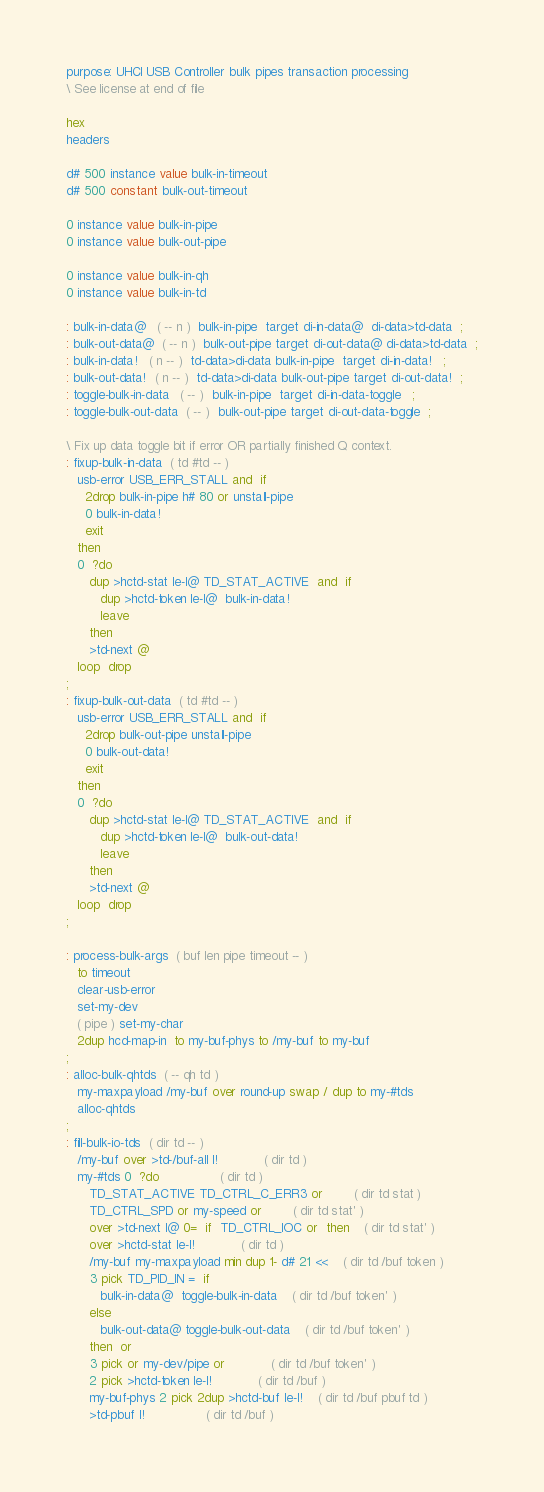<code> <loc_0><loc_0><loc_500><loc_500><_Forth_>purpose: UHCI USB Controller bulk pipes transaction processing
\ See license at end of file

hex
headers

d# 500 instance value bulk-in-timeout
d# 500 constant bulk-out-timeout

0 instance value bulk-in-pipe
0 instance value bulk-out-pipe

0 instance value bulk-in-qh
0 instance value bulk-in-td

: bulk-in-data@   ( -- n )  bulk-in-pipe  target di-in-data@  di-data>td-data  ;
: bulk-out-data@  ( -- n )  bulk-out-pipe target di-out-data@ di-data>td-data  ;
: bulk-in-data!   ( n -- )  td-data>di-data bulk-in-pipe  target di-in-data!   ;
: bulk-out-data!  ( n -- )  td-data>di-data bulk-out-pipe target di-out-data!  ;
: toggle-bulk-in-data   ( -- )  bulk-in-pipe  target di-in-data-toggle   ;
: toggle-bulk-out-data  ( -- )  bulk-out-pipe target di-out-data-toggle  ;

\ Fix up data toggle bit if error OR partially finished Q context.
: fixup-bulk-in-data  ( td #td -- )
   usb-error USB_ERR_STALL and  if
     2drop bulk-in-pipe h# 80 or unstall-pipe
     0 bulk-in-data!
     exit
   then
   0  ?do
      dup >hctd-stat le-l@ TD_STAT_ACTIVE  and  if
         dup >hctd-token le-l@  bulk-in-data!
         leave
      then
      >td-next @
   loop  drop
;
: fixup-bulk-out-data  ( td #td -- )
   usb-error USB_ERR_STALL and  if
     2drop bulk-out-pipe unstall-pipe
     0 bulk-out-data!
     exit
   then
   0  ?do
      dup >hctd-stat le-l@ TD_STAT_ACTIVE  and  if
         dup >hctd-token le-l@  bulk-out-data!
         leave
      then
      >td-next @
   loop  drop
;

: process-bulk-args  ( buf len pipe timeout -- )
   to timeout
   clear-usb-error
   set-my-dev
   ( pipe ) set-my-char
   2dup hcd-map-in  to my-buf-phys to /my-buf to my-buf
;
: alloc-bulk-qhtds  ( -- qh td )
   my-maxpayload /my-buf over round-up swap / dup to my-#tds
   alloc-qhtds
;
: fill-bulk-io-tds  ( dir td -- )
   /my-buf over >td-/buf-all l!			( dir td )
   my-#tds 0  ?do				( dir td )
      TD_STAT_ACTIVE TD_CTRL_C_ERR3 or		( dir td stat )
      TD_CTRL_SPD or my-speed or		( dir td stat' )
      over >td-next l@ 0=  if  TD_CTRL_IOC or  then	( dir td stat' )
      over >hctd-stat le-l!			( dir td )
      /my-buf my-maxpayload min dup 1- d# 21 <<	( dir td /buf token )
      3 pick TD_PID_IN =  if
         bulk-in-data@  toggle-bulk-in-data	( dir td /buf token' )
      else
         bulk-out-data@ toggle-bulk-out-data	( dir td /buf token' )
      then  or
      3 pick or my-dev/pipe or			( dir td /buf token' )
      2 pick >hctd-token le-l!			( dir td /buf )
      my-buf-phys 2 pick 2dup >hctd-buf le-l!	( dir td /buf pbuf td )
      >td-pbuf l!				( dir td /buf )</code> 